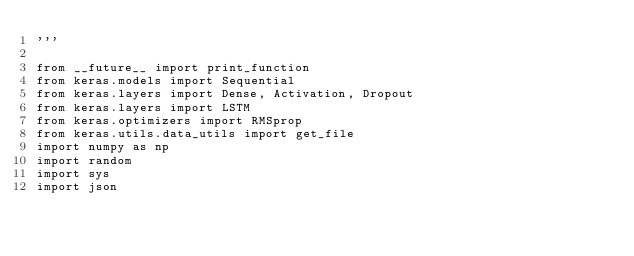<code> <loc_0><loc_0><loc_500><loc_500><_Python_>'''

from __future__ import print_function
from keras.models import Sequential
from keras.layers import Dense, Activation, Dropout
from keras.layers import LSTM
from keras.optimizers import RMSprop
from keras.utils.data_utils import get_file
import numpy as np
import random
import sys
import json
</code> 